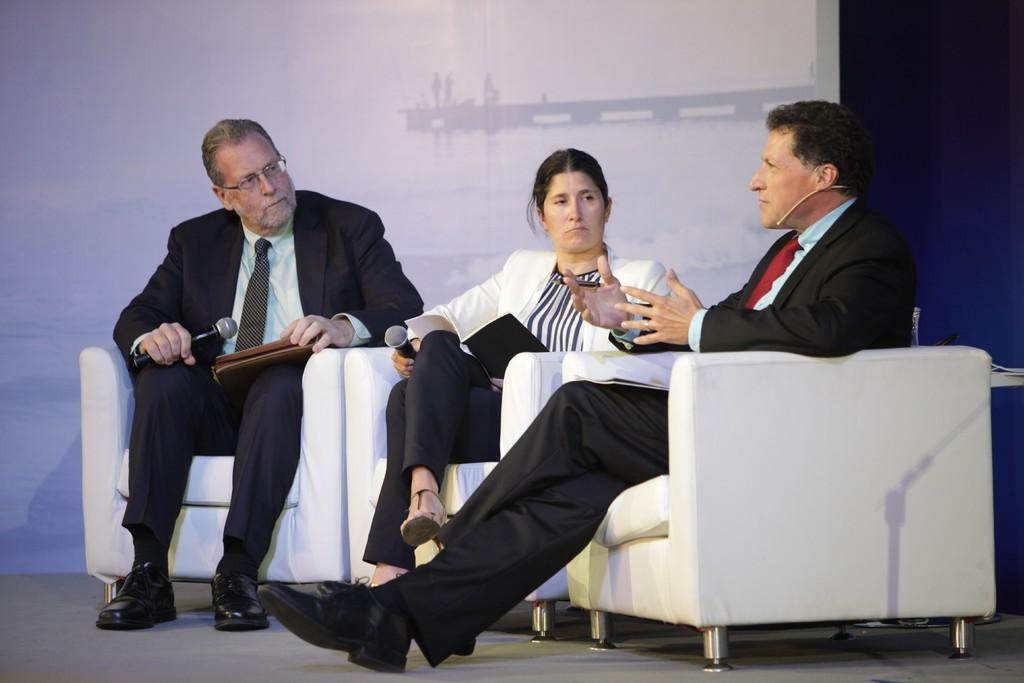How many people are seated on the sofa in the image? There are three people seated on the sofa in the image. What is one person doing in the image? One person is speaking in the right side of the image. What objects are being held by two of the people in the image? Two of the people are holding microphones in their hands. What type of oven is visible in the image? There is no oven present in the image. What is the writer doing in the image? There is no writer present in the image. 